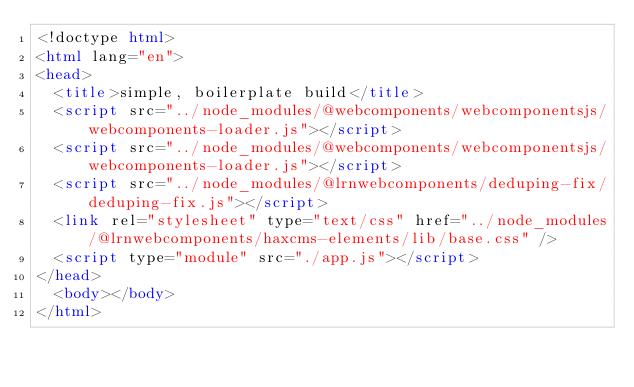<code> <loc_0><loc_0><loc_500><loc_500><_HTML_><!doctype html>
<html lang="en">
<head>
  <title>simple, boilerplate build</title>
  <script src="../node_modules/@webcomponents/webcomponentsjs/webcomponents-loader.js"></script>
  <script src="../node_modules/@webcomponents/webcomponentsjs/webcomponents-loader.js"></script>
  <script src="../node_modules/@lrnwebcomponents/deduping-fix/deduping-fix.js"></script>
  <link rel="stylesheet" type="text/css" href="../node_modules/@lrnwebcomponents/haxcms-elements/lib/base.css" />
  <script type="module" src="./app.js"></script>
</head>
  <body></body>
</html></code> 